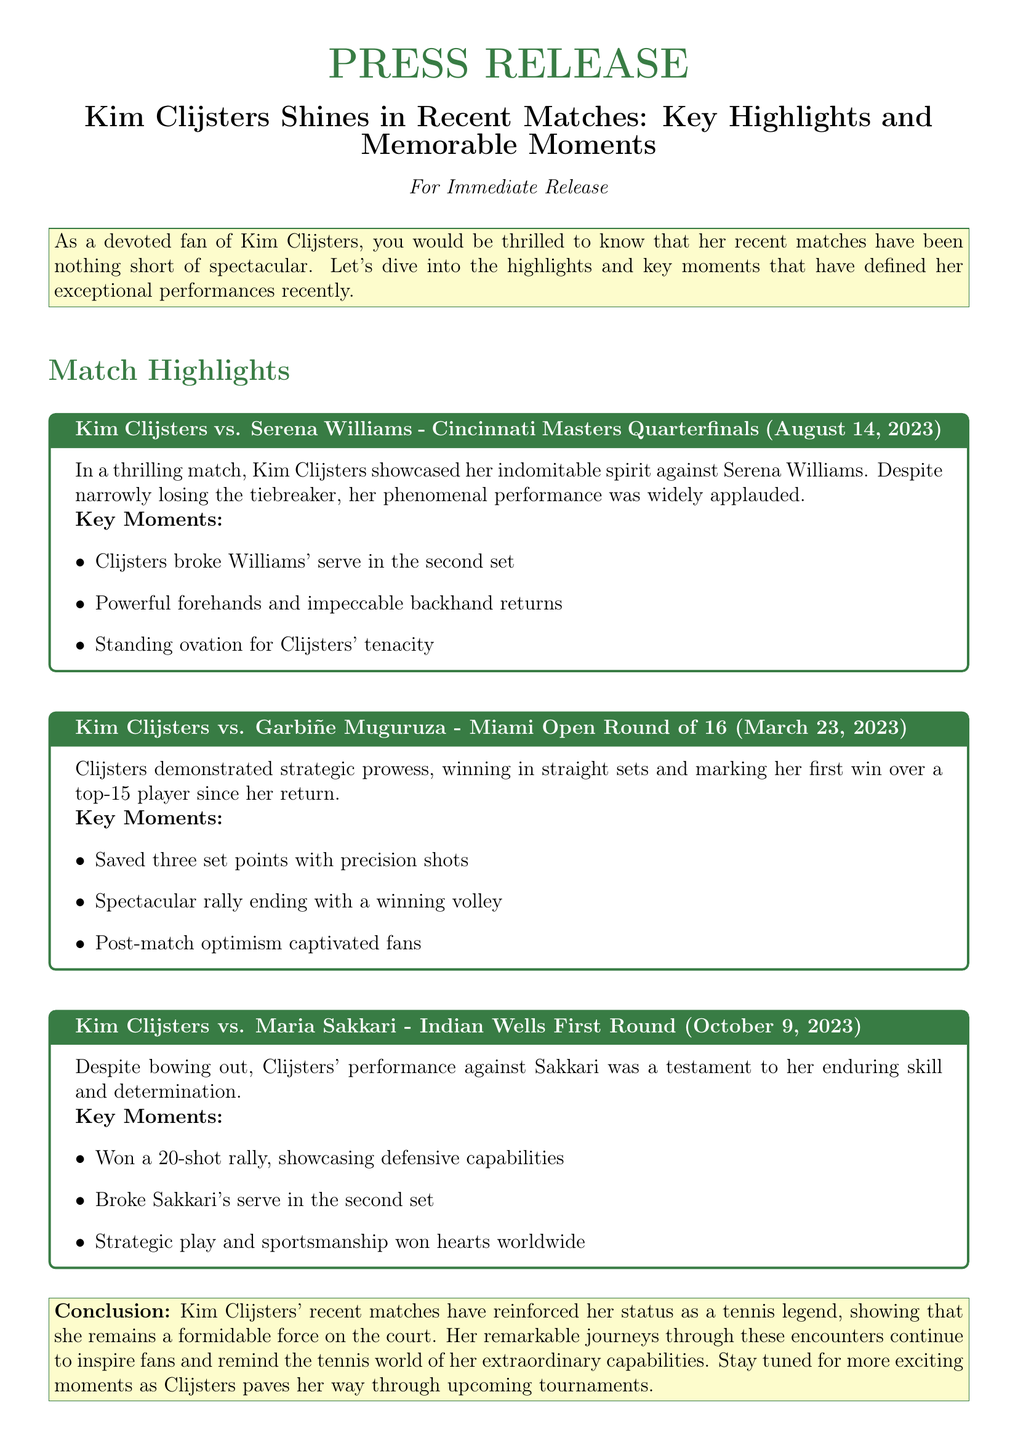what was the date of Clijsters' match against Serena Williams? The match against Serena Williams took place on August 14, 2023.
Answer: August 14, 2023 how many set points did Clijsters save against Garbiñe Muguruza? Clijsters saved three set points with precision shots in her match against Muguruza.
Answer: three what is the title of the Press Release? The title of the Press Release is mentioned at the beginning and is "Kim Clijsters Shines in Recent Matches: Key Highlights and Memorable Moments."
Answer: Kim Clijsters Shines in Recent Matches: Key Highlights and Memorable Moments which player did Clijsters face in the Indian Wells First Round? Clijsters faced Maria Sakkari in the Indian Wells First Round.
Answer: Maria Sakkari what notable moment occurred in the match against Serena Williams? Clijsters broke Williams' serve in the second set, showcasing her impressive skill.
Answer: broke Williams' serve how did Clijsters demonstrate her prowess in the match against Muguruza? Clijsters demonstrated her strategic prowess by winning in straight sets.
Answer: winning in straight sets what was the outcome of Clijsters' match against Maria Sakkari? The outcome was that Clijsters bowed out in the match against Sakkari.
Answer: bowed out what is the conclusion about Clijsters' recent matches? The conclusion emphasizes that Clijsters continues to be a formidable force and inspires fans through her performances.
Answer: a formidable force 